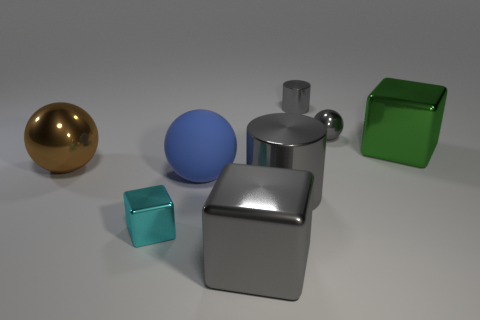Add 2 gray cylinders. How many objects exist? 10 Subtract all cylinders. How many objects are left? 6 Add 6 small gray spheres. How many small gray spheres exist? 7 Subtract 0 blue cylinders. How many objects are left? 8 Subtract all small cyan blocks. Subtract all big red rubber blocks. How many objects are left? 7 Add 7 small cyan metal blocks. How many small cyan metal blocks are left? 8 